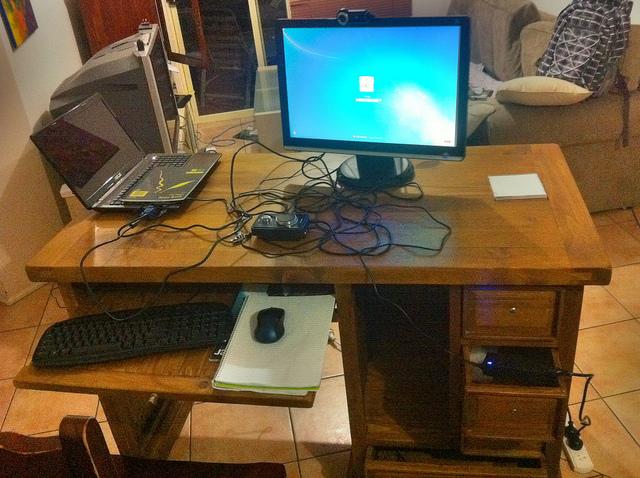Is the computer at a desk?
Answer briefly. Yes. What room is this in?
Give a very brief answer. Living room. Is the Apple device turned on?
Concise answer only. Yes. Are the cords organized neatly?
Answer briefly. No. 